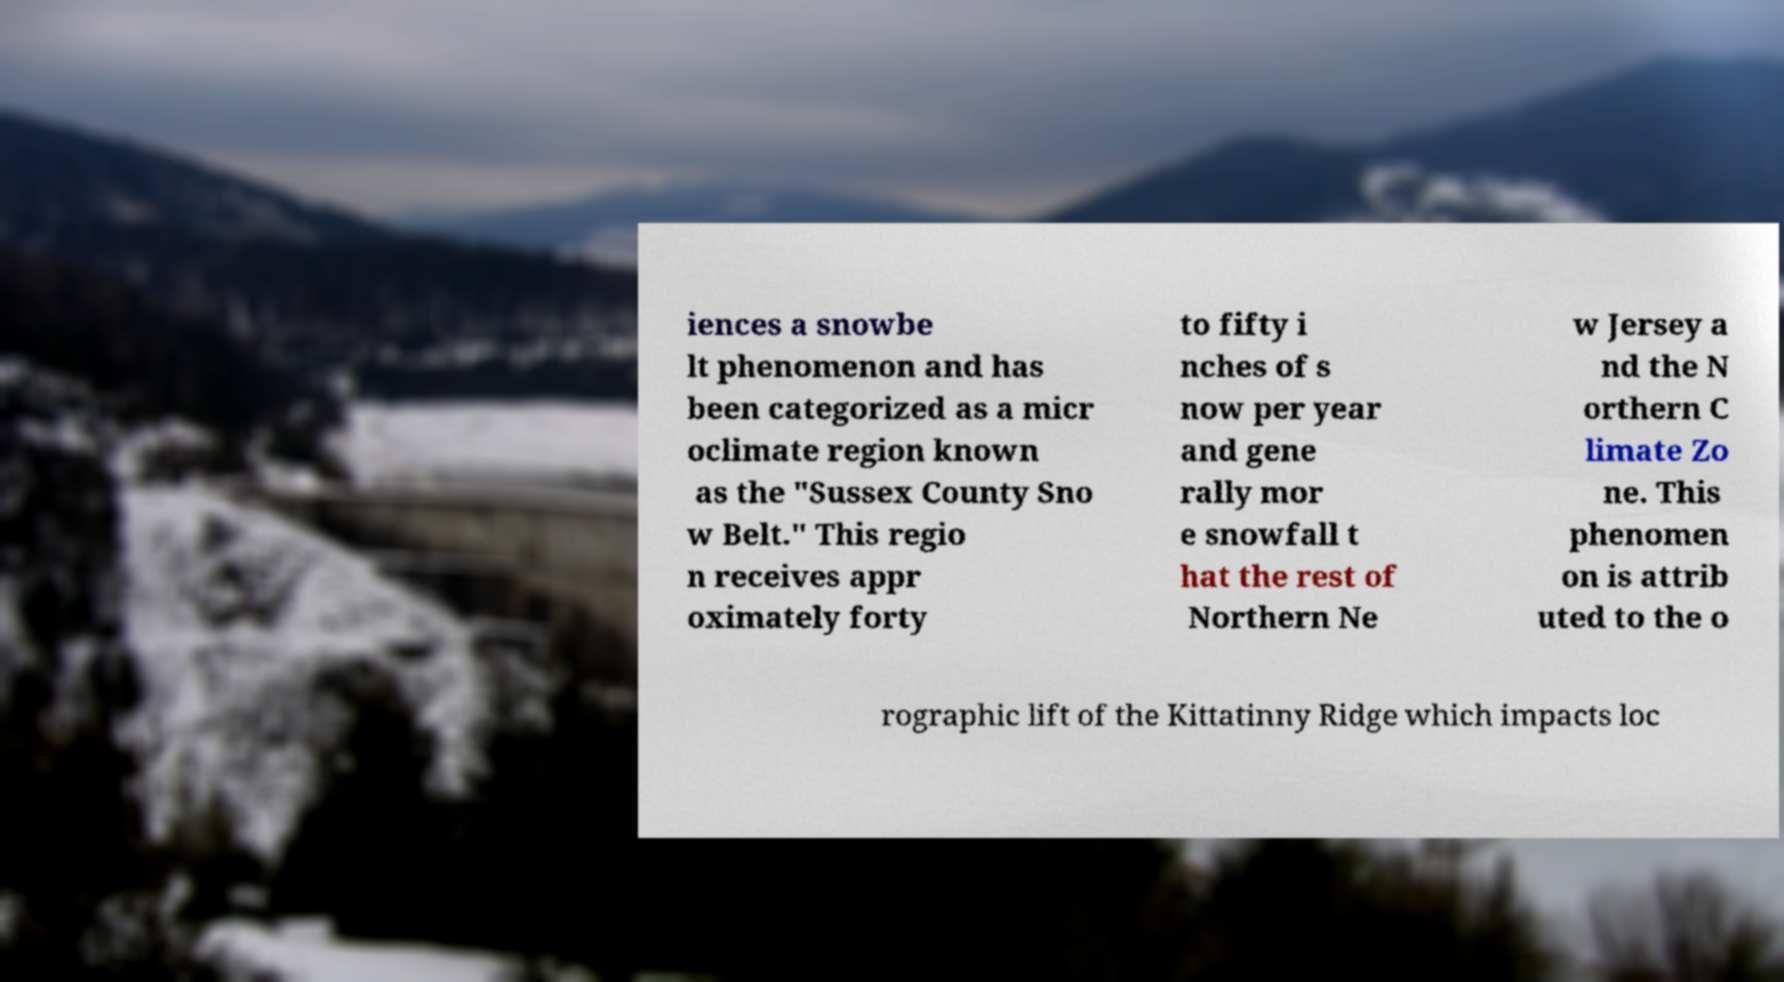I need the written content from this picture converted into text. Can you do that? iences a snowbe lt phenomenon and has been categorized as a micr oclimate region known as the "Sussex County Sno w Belt." This regio n receives appr oximately forty to fifty i nches of s now per year and gene rally mor e snowfall t hat the rest of Northern Ne w Jersey a nd the N orthern C limate Zo ne. This phenomen on is attrib uted to the o rographic lift of the Kittatinny Ridge which impacts loc 